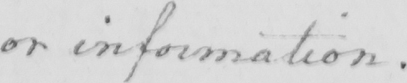Please provide the text content of this handwritten line. or information . 